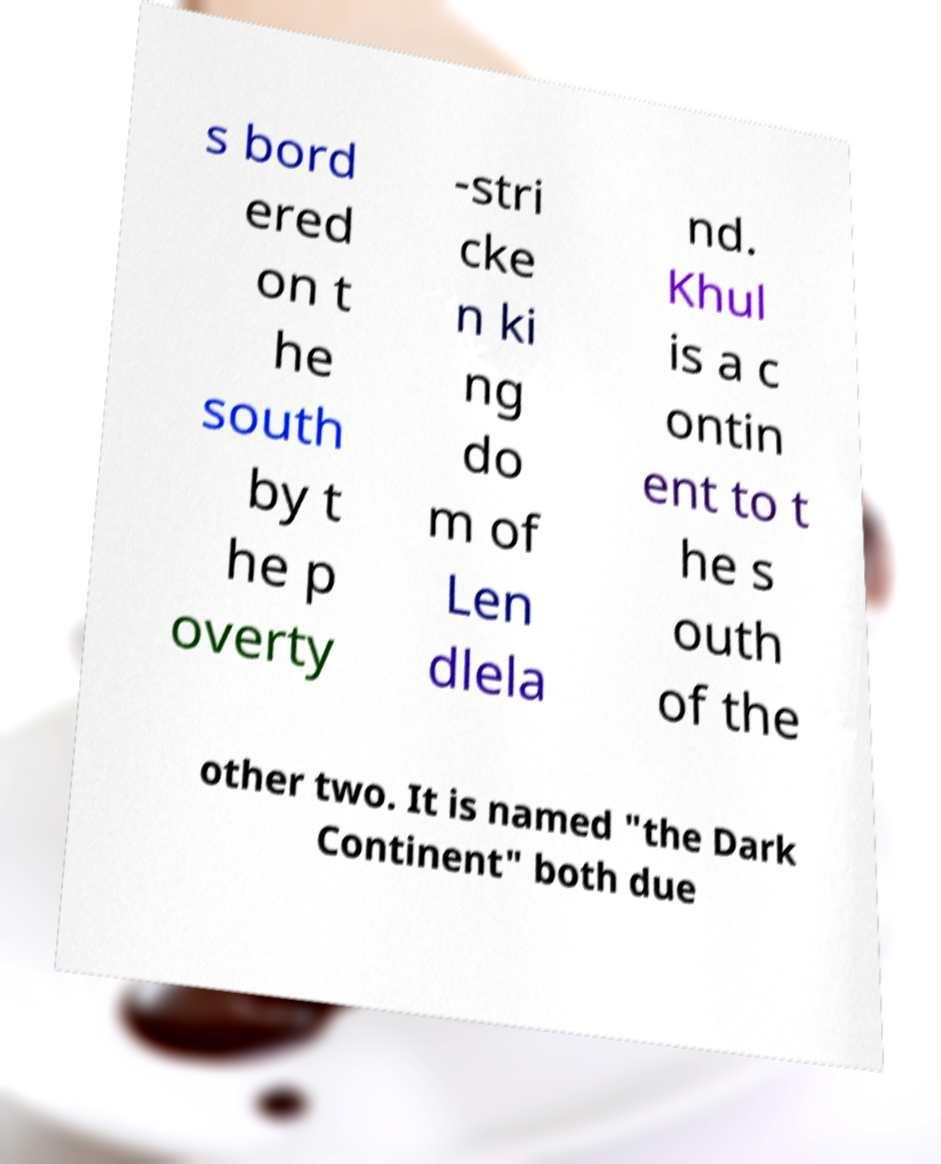Please identify and transcribe the text found in this image. s bord ered on t he south by t he p overty -stri cke n ki ng do m of Len dlela nd. Khul is a c ontin ent to t he s outh of the other two. It is named "the Dark Continent" both due 